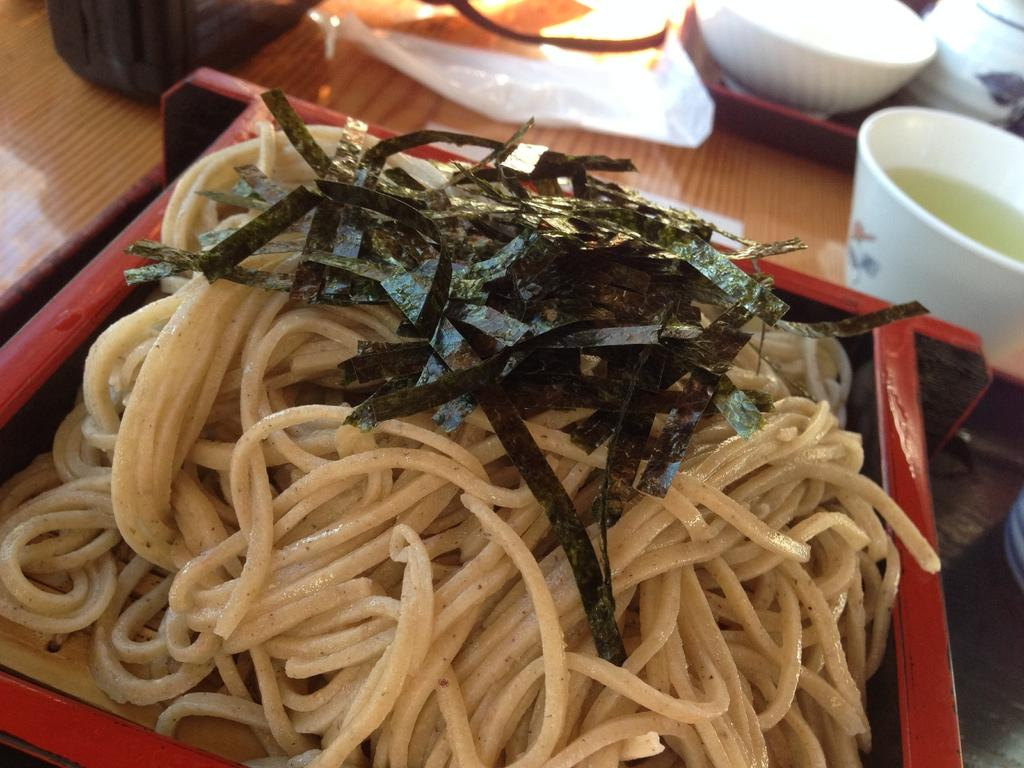What piece of furniture is present in the image? There is a table in the image. What is placed on the table? There is a cup, a paper, a bowl, and a tray on the table. What is inside the bowl? The facts do not specify what is inside the bowl. What is contained in the tray? There are food items in the tray. What type of quilt is draped over the table in the image? There is no quilt present in the image; it only features a table with various items on it. What kind of meal is being prepared in the image? The facts do not indicate that a meal is being prepared in the image. 